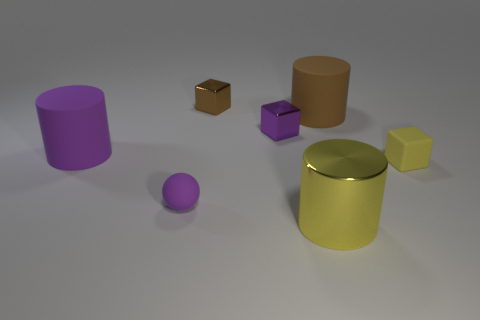Are the small purple thing in front of the tiny purple shiny object and the brown block made of the same material?
Offer a very short reply. No. Is there a cyan shiny sphere?
Your answer should be compact. No. What is the color of the tiny object that is made of the same material as the tiny brown block?
Your answer should be compact. Purple. What color is the tiny thing that is in front of the small block that is in front of the purple rubber object behind the tiny purple ball?
Offer a terse response. Purple. Is the size of the ball the same as the object behind the big brown cylinder?
Ensure brevity in your answer.  Yes. What number of things are either purple metal things that are to the left of the yellow cube or matte things that are on the left side of the tiny purple metallic thing?
Give a very brief answer. 3. What shape is the yellow matte thing that is the same size as the matte ball?
Your answer should be compact. Cube. What shape is the large matte object behind the big rubber cylinder that is left of the cylinder in front of the small yellow rubber thing?
Offer a terse response. Cylinder. Are there the same number of purple matte objects in front of the shiny cylinder and tiny green shiny cylinders?
Your response must be concise. Yes. Does the metal cylinder have the same size as the brown matte thing?
Provide a succinct answer. Yes. 